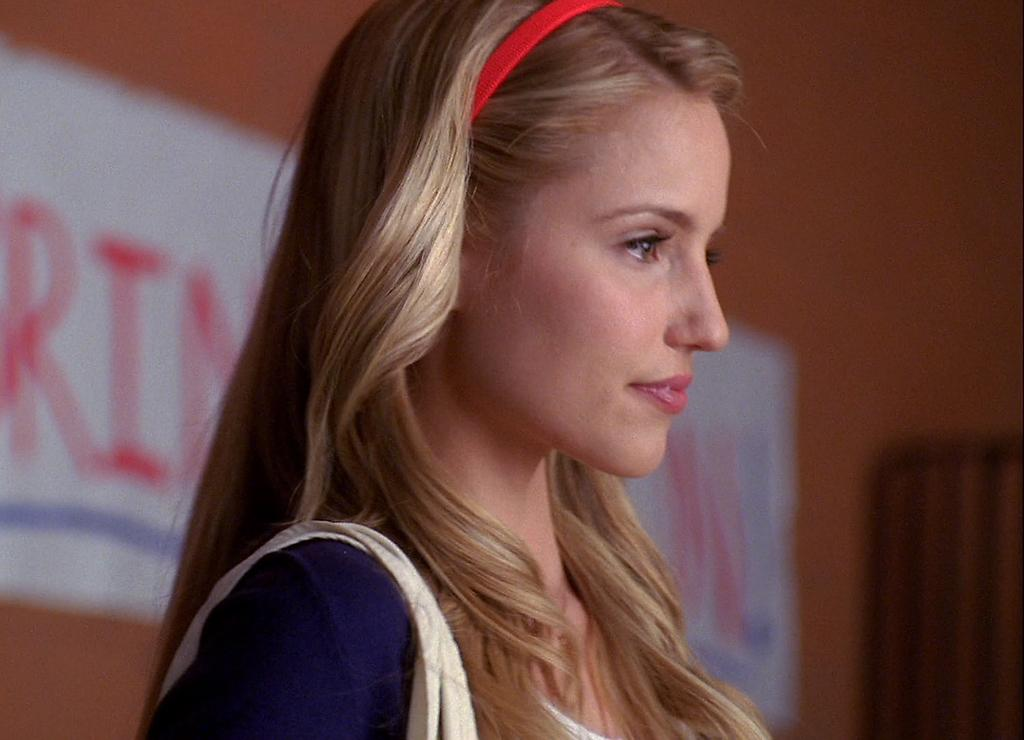Who is the main subject in the image? There is a girl in the image. What is the girl doing in the image? The girl is standing in the image. In which direction is the girl looking? The girl is looking to the right side of the image. What can be seen in the background of the image? There is a wall in the background of the image. What type of nose can be seen on the girl's side in the image? There is no nose visible on the girl's side in the image. 